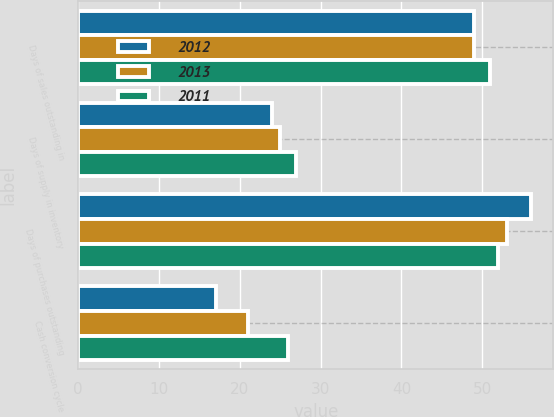<chart> <loc_0><loc_0><loc_500><loc_500><stacked_bar_chart><ecel><fcel>Days of sales outstanding in<fcel>Days of supply in inventory<fcel>Days of purchases outstanding<fcel>Cash conversion cycle<nl><fcel>2012<fcel>49<fcel>24<fcel>56<fcel>17<nl><fcel>2013<fcel>49<fcel>25<fcel>53<fcel>21<nl><fcel>2011<fcel>51<fcel>27<fcel>52<fcel>26<nl></chart> 